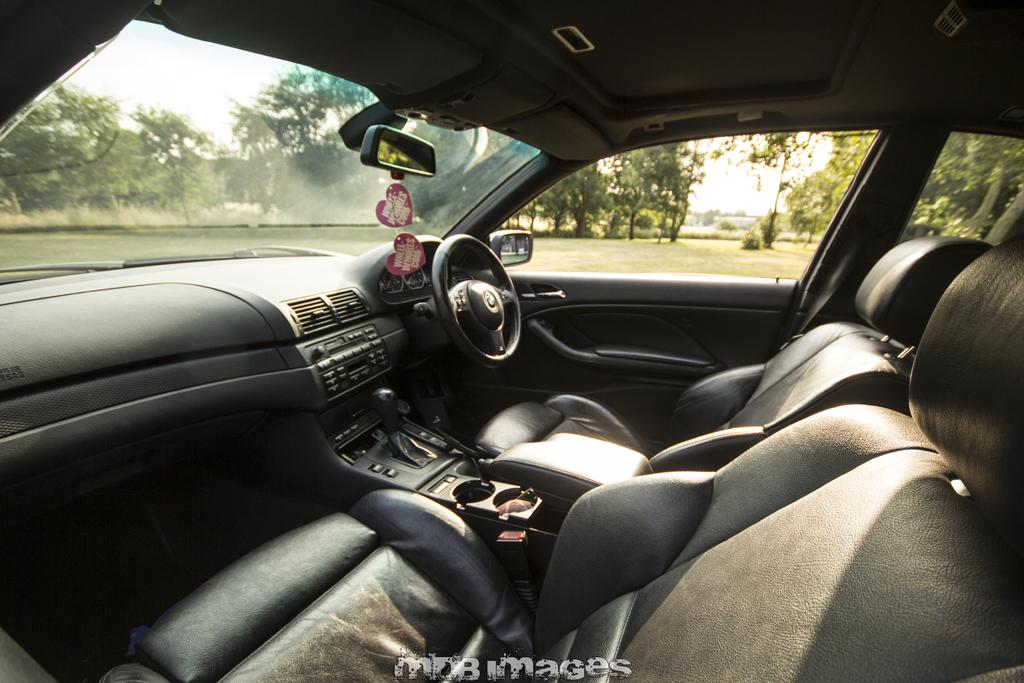What type of setting is depicted in the image? The image shows the interior of a car. What can be seen outside of the car in the image? The ground is visible in the image, as well as trees and the sky. What type of stamp can be seen on the car's dashboard in the image? There is no stamp visible on the car's dashboard in the image. 